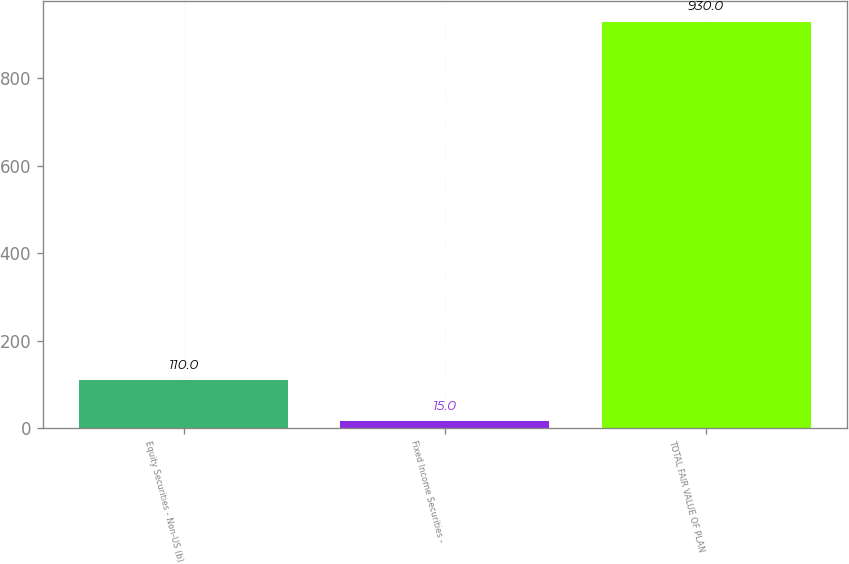Convert chart to OTSL. <chart><loc_0><loc_0><loc_500><loc_500><bar_chart><fcel>Equity Securities - Non-US (b)<fcel>Fixed Income Securities -<fcel>TOTAL FAIR VALUE OF PLAN<nl><fcel>110<fcel>15<fcel>930<nl></chart> 